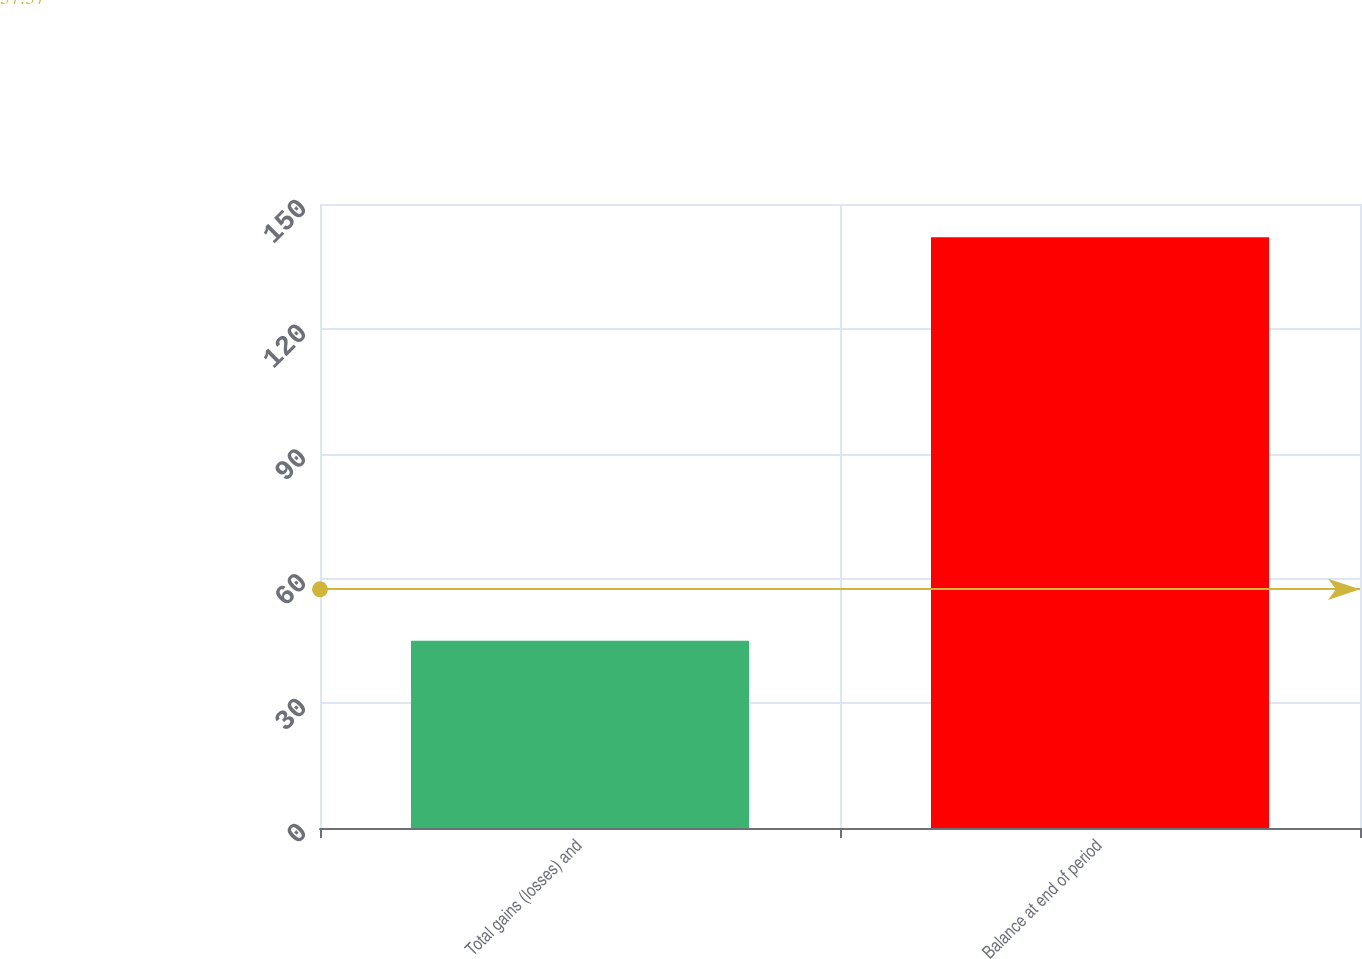Convert chart to OTSL. <chart><loc_0><loc_0><loc_500><loc_500><bar_chart><fcel>Total gains (losses) and<fcel>Balance at end of period<nl><fcel>45<fcel>142<nl></chart> 